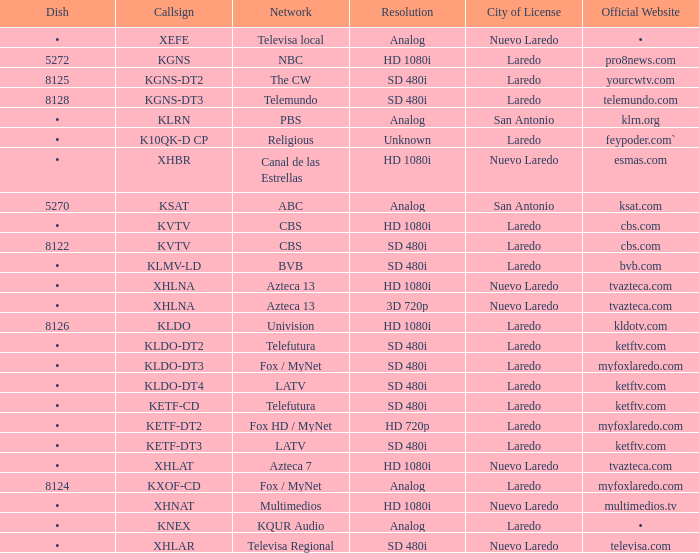Name the resolution for dish of 5270 Analog. 